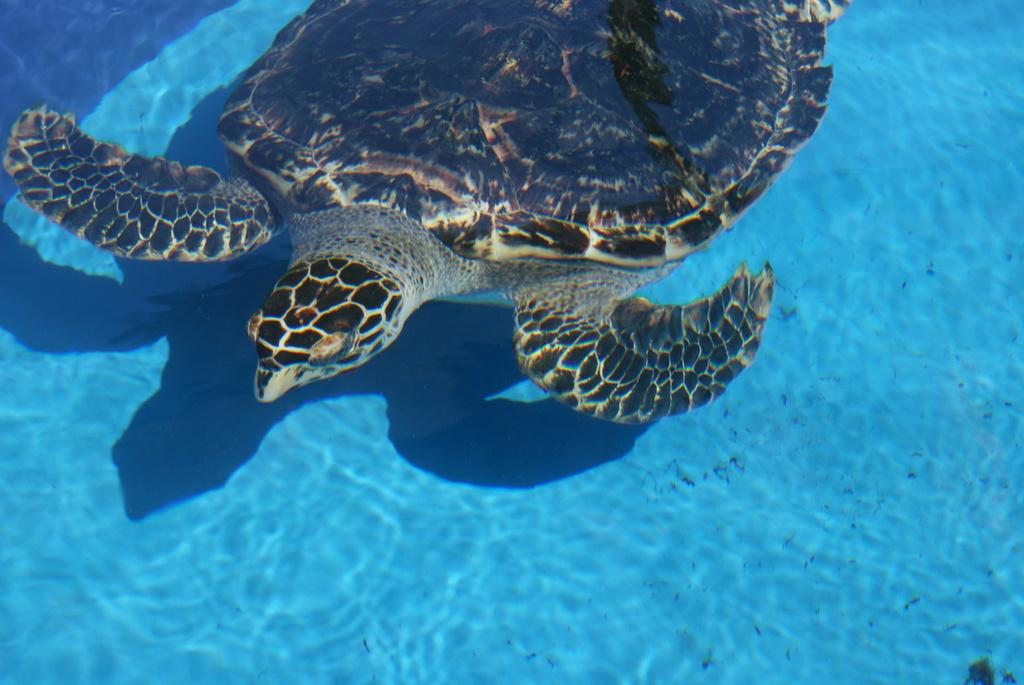What animal is present in the image? There is a tortoise in the image. Where is the tortoise located? The tortoise is in the water. What type of fuel is the tortoise using to swim in the image? Tortoises do not use fuel to swim; they move using their limbs and shell. 